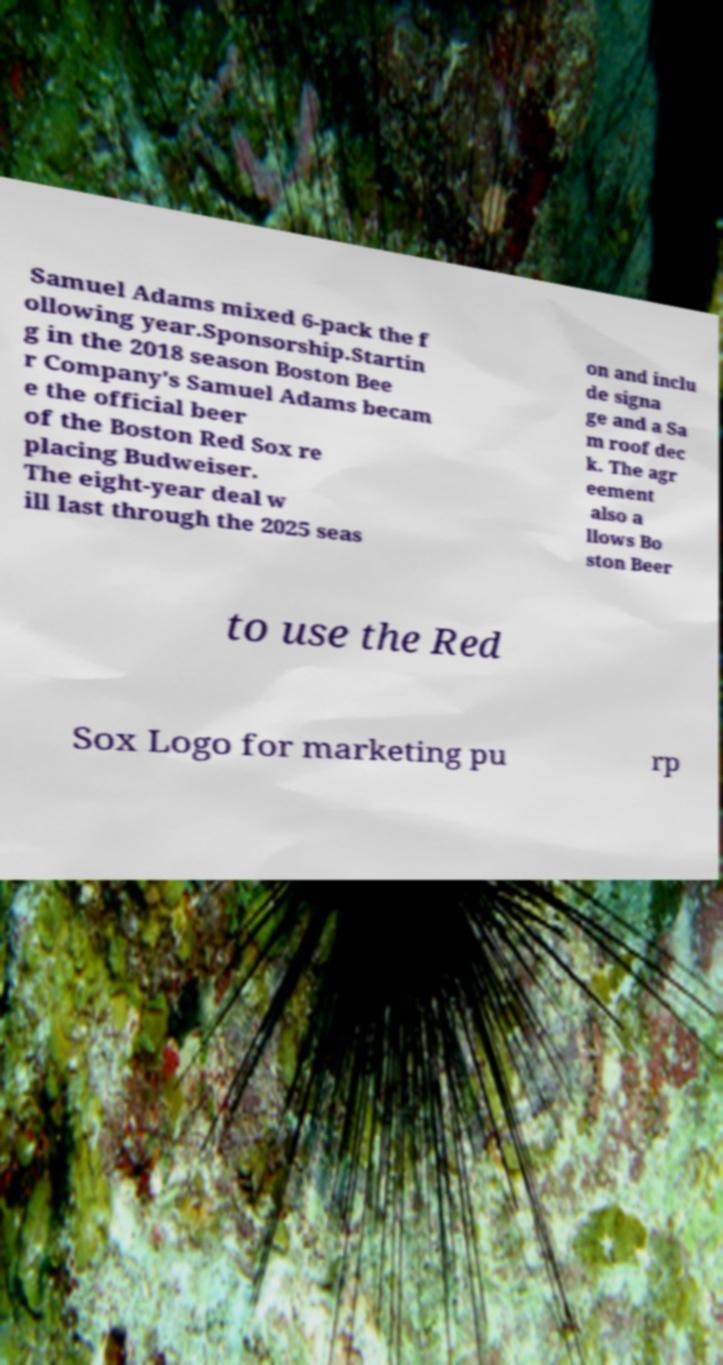There's text embedded in this image that I need extracted. Can you transcribe it verbatim? Samuel Adams mixed 6-pack the f ollowing year.Sponsorship.Startin g in the 2018 season Boston Bee r Company's Samuel Adams becam e the official beer of the Boston Red Sox re placing Budweiser. The eight-year deal w ill last through the 2025 seas on and inclu de signa ge and a Sa m roof dec k. The agr eement also a llows Bo ston Beer to use the Red Sox Logo for marketing pu rp 